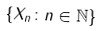Convert formula to latex. <formula><loc_0><loc_0><loc_500><loc_500>\{ X _ { n } \colon n \in \mathbb { N } \}</formula> 